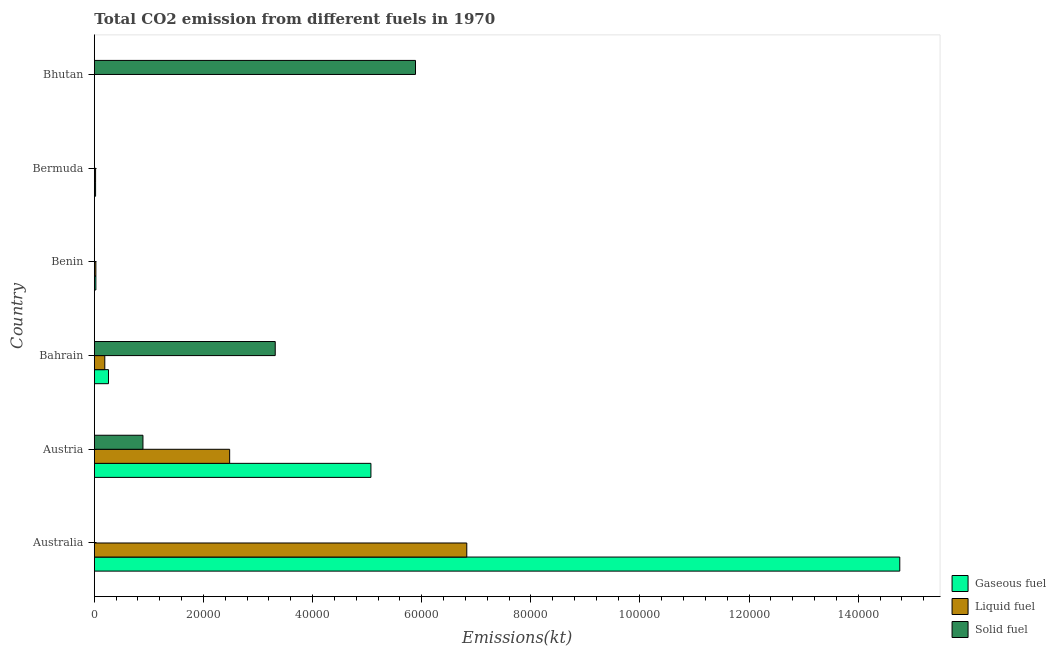How many different coloured bars are there?
Make the answer very short. 3. Are the number of bars per tick equal to the number of legend labels?
Keep it short and to the point. Yes. Are the number of bars on each tick of the Y-axis equal?
Your response must be concise. Yes. How many bars are there on the 5th tick from the top?
Your answer should be very brief. 3. What is the label of the 6th group of bars from the top?
Provide a short and direct response. Australia. In how many cases, is the number of bars for a given country not equal to the number of legend labels?
Your answer should be compact. 0. What is the amount of co2 emissions from gaseous fuel in Austria?
Your response must be concise. 5.07e+04. Across all countries, what is the maximum amount of co2 emissions from gaseous fuel?
Your answer should be very brief. 1.48e+05. Across all countries, what is the minimum amount of co2 emissions from liquid fuel?
Ensure brevity in your answer.  3.67. In which country was the amount of co2 emissions from gaseous fuel maximum?
Keep it short and to the point. Australia. What is the total amount of co2 emissions from liquid fuel in the graph?
Make the answer very short. 9.55e+04. What is the difference between the amount of co2 emissions from gaseous fuel in Australia and that in Benin?
Give a very brief answer. 1.47e+05. What is the difference between the amount of co2 emissions from solid fuel in Austria and the amount of co2 emissions from liquid fuel in Bahrain?
Your response must be concise. 6992.97. What is the average amount of co2 emissions from gaseous fuel per country?
Ensure brevity in your answer.  3.36e+04. What is the difference between the amount of co2 emissions from gaseous fuel and amount of co2 emissions from solid fuel in Austria?
Ensure brevity in your answer.  4.18e+04. What is the ratio of the amount of co2 emissions from liquid fuel in Austria to that in Bhutan?
Offer a very short reply. 6763. Is the difference between the amount of co2 emissions from gaseous fuel in Australia and Austria greater than the difference between the amount of co2 emissions from liquid fuel in Australia and Austria?
Provide a succinct answer. Yes. What is the difference between the highest and the second highest amount of co2 emissions from solid fuel?
Keep it short and to the point. 2.57e+04. What is the difference between the highest and the lowest amount of co2 emissions from solid fuel?
Provide a succinct answer. 5.89e+04. Is the sum of the amount of co2 emissions from liquid fuel in Austria and Bermuda greater than the maximum amount of co2 emissions from gaseous fuel across all countries?
Your answer should be compact. No. What does the 2nd bar from the top in Bahrain represents?
Your response must be concise. Liquid fuel. What does the 1st bar from the bottom in Austria represents?
Your answer should be compact. Gaseous fuel. Are all the bars in the graph horizontal?
Provide a succinct answer. Yes. What is the difference between two consecutive major ticks on the X-axis?
Make the answer very short. 2.00e+04. Are the values on the major ticks of X-axis written in scientific E-notation?
Provide a succinct answer. No. Does the graph contain grids?
Offer a terse response. No. Where does the legend appear in the graph?
Your answer should be very brief. Bottom right. What is the title of the graph?
Offer a very short reply. Total CO2 emission from different fuels in 1970. What is the label or title of the X-axis?
Your answer should be compact. Emissions(kt). What is the Emissions(kt) in Gaseous fuel in Australia?
Your response must be concise. 1.48e+05. What is the Emissions(kt) in Liquid fuel in Australia?
Give a very brief answer. 6.83e+04. What is the Emissions(kt) of Solid fuel in Australia?
Your answer should be compact. 3.67. What is the Emissions(kt) in Gaseous fuel in Austria?
Provide a succinct answer. 5.07e+04. What is the Emissions(kt) in Liquid fuel in Austria?
Offer a very short reply. 2.48e+04. What is the Emissions(kt) of Solid fuel in Austria?
Offer a very short reply. 8910.81. What is the Emissions(kt) in Gaseous fuel in Bahrain?
Give a very brief answer. 2592.57. What is the Emissions(kt) of Liquid fuel in Bahrain?
Provide a short and direct response. 1917.84. What is the Emissions(kt) in Solid fuel in Bahrain?
Your answer should be compact. 3.32e+04. What is the Emissions(kt) of Gaseous fuel in Benin?
Keep it short and to the point. 282.36. What is the Emissions(kt) in Liquid fuel in Benin?
Keep it short and to the point. 282.36. What is the Emissions(kt) of Solid fuel in Benin?
Give a very brief answer. 33. What is the Emissions(kt) of Gaseous fuel in Bermuda?
Offer a terse response. 227.35. What is the Emissions(kt) in Liquid fuel in Bermuda?
Keep it short and to the point. 227.35. What is the Emissions(kt) in Solid fuel in Bermuda?
Provide a succinct answer. 3.67. What is the Emissions(kt) in Gaseous fuel in Bhutan?
Your response must be concise. 3.67. What is the Emissions(kt) of Liquid fuel in Bhutan?
Make the answer very short. 3.67. What is the Emissions(kt) of Solid fuel in Bhutan?
Offer a terse response. 5.89e+04. Across all countries, what is the maximum Emissions(kt) in Gaseous fuel?
Your answer should be very brief. 1.48e+05. Across all countries, what is the maximum Emissions(kt) of Liquid fuel?
Ensure brevity in your answer.  6.83e+04. Across all countries, what is the maximum Emissions(kt) in Solid fuel?
Your answer should be very brief. 5.89e+04. Across all countries, what is the minimum Emissions(kt) of Gaseous fuel?
Offer a terse response. 3.67. Across all countries, what is the minimum Emissions(kt) in Liquid fuel?
Give a very brief answer. 3.67. Across all countries, what is the minimum Emissions(kt) in Solid fuel?
Your answer should be very brief. 3.67. What is the total Emissions(kt) in Gaseous fuel in the graph?
Give a very brief answer. 2.01e+05. What is the total Emissions(kt) of Liquid fuel in the graph?
Offer a very short reply. 9.55e+04. What is the total Emissions(kt) of Solid fuel in the graph?
Your answer should be very brief. 1.01e+05. What is the difference between the Emissions(kt) in Gaseous fuel in Australia and that in Austria?
Your answer should be very brief. 9.69e+04. What is the difference between the Emissions(kt) in Liquid fuel in Australia and that in Austria?
Your answer should be very brief. 4.35e+04. What is the difference between the Emissions(kt) in Solid fuel in Australia and that in Austria?
Offer a terse response. -8907.14. What is the difference between the Emissions(kt) in Gaseous fuel in Australia and that in Bahrain?
Provide a succinct answer. 1.45e+05. What is the difference between the Emissions(kt) in Liquid fuel in Australia and that in Bahrain?
Offer a terse response. 6.63e+04. What is the difference between the Emissions(kt) of Solid fuel in Australia and that in Bahrain?
Give a very brief answer. -3.31e+04. What is the difference between the Emissions(kt) in Gaseous fuel in Australia and that in Benin?
Keep it short and to the point. 1.47e+05. What is the difference between the Emissions(kt) in Liquid fuel in Australia and that in Benin?
Offer a very short reply. 6.80e+04. What is the difference between the Emissions(kt) of Solid fuel in Australia and that in Benin?
Make the answer very short. -29.34. What is the difference between the Emissions(kt) of Gaseous fuel in Australia and that in Bermuda?
Your answer should be compact. 1.47e+05. What is the difference between the Emissions(kt) of Liquid fuel in Australia and that in Bermuda?
Make the answer very short. 6.80e+04. What is the difference between the Emissions(kt) of Gaseous fuel in Australia and that in Bhutan?
Your answer should be very brief. 1.48e+05. What is the difference between the Emissions(kt) in Liquid fuel in Australia and that in Bhutan?
Your answer should be compact. 6.83e+04. What is the difference between the Emissions(kt) of Solid fuel in Australia and that in Bhutan?
Ensure brevity in your answer.  -5.89e+04. What is the difference between the Emissions(kt) of Gaseous fuel in Austria and that in Bahrain?
Your answer should be very brief. 4.81e+04. What is the difference between the Emissions(kt) in Liquid fuel in Austria and that in Bahrain?
Give a very brief answer. 2.29e+04. What is the difference between the Emissions(kt) in Solid fuel in Austria and that in Bahrain?
Ensure brevity in your answer.  -2.42e+04. What is the difference between the Emissions(kt) in Gaseous fuel in Austria and that in Benin?
Your response must be concise. 5.04e+04. What is the difference between the Emissions(kt) in Liquid fuel in Austria and that in Benin?
Keep it short and to the point. 2.45e+04. What is the difference between the Emissions(kt) of Solid fuel in Austria and that in Benin?
Your response must be concise. 8877.81. What is the difference between the Emissions(kt) of Gaseous fuel in Austria and that in Bermuda?
Give a very brief answer. 5.05e+04. What is the difference between the Emissions(kt) in Liquid fuel in Austria and that in Bermuda?
Your answer should be compact. 2.46e+04. What is the difference between the Emissions(kt) of Solid fuel in Austria and that in Bermuda?
Your response must be concise. 8907.14. What is the difference between the Emissions(kt) in Gaseous fuel in Austria and that in Bhutan?
Provide a short and direct response. 5.07e+04. What is the difference between the Emissions(kt) of Liquid fuel in Austria and that in Bhutan?
Keep it short and to the point. 2.48e+04. What is the difference between the Emissions(kt) in Solid fuel in Austria and that in Bhutan?
Your answer should be compact. -5.00e+04. What is the difference between the Emissions(kt) of Gaseous fuel in Bahrain and that in Benin?
Your answer should be compact. 2310.21. What is the difference between the Emissions(kt) of Liquid fuel in Bahrain and that in Benin?
Make the answer very short. 1635.48. What is the difference between the Emissions(kt) in Solid fuel in Bahrain and that in Benin?
Your answer should be very brief. 3.31e+04. What is the difference between the Emissions(kt) of Gaseous fuel in Bahrain and that in Bermuda?
Your answer should be compact. 2365.22. What is the difference between the Emissions(kt) of Liquid fuel in Bahrain and that in Bermuda?
Ensure brevity in your answer.  1690.49. What is the difference between the Emissions(kt) of Solid fuel in Bahrain and that in Bermuda?
Make the answer very short. 3.31e+04. What is the difference between the Emissions(kt) in Gaseous fuel in Bahrain and that in Bhutan?
Provide a short and direct response. 2588.9. What is the difference between the Emissions(kt) of Liquid fuel in Bahrain and that in Bhutan?
Keep it short and to the point. 1914.17. What is the difference between the Emissions(kt) in Solid fuel in Bahrain and that in Bhutan?
Offer a terse response. -2.57e+04. What is the difference between the Emissions(kt) of Gaseous fuel in Benin and that in Bermuda?
Your answer should be very brief. 55.01. What is the difference between the Emissions(kt) in Liquid fuel in Benin and that in Bermuda?
Provide a succinct answer. 55.01. What is the difference between the Emissions(kt) in Solid fuel in Benin and that in Bermuda?
Your answer should be compact. 29.34. What is the difference between the Emissions(kt) of Gaseous fuel in Benin and that in Bhutan?
Your answer should be very brief. 278.69. What is the difference between the Emissions(kt) in Liquid fuel in Benin and that in Bhutan?
Make the answer very short. 278.69. What is the difference between the Emissions(kt) in Solid fuel in Benin and that in Bhutan?
Make the answer very short. -5.88e+04. What is the difference between the Emissions(kt) of Gaseous fuel in Bermuda and that in Bhutan?
Offer a terse response. 223.69. What is the difference between the Emissions(kt) of Liquid fuel in Bermuda and that in Bhutan?
Provide a succinct answer. 223.69. What is the difference between the Emissions(kt) of Solid fuel in Bermuda and that in Bhutan?
Your answer should be compact. -5.89e+04. What is the difference between the Emissions(kt) in Gaseous fuel in Australia and the Emissions(kt) in Liquid fuel in Austria?
Ensure brevity in your answer.  1.23e+05. What is the difference between the Emissions(kt) in Gaseous fuel in Australia and the Emissions(kt) in Solid fuel in Austria?
Ensure brevity in your answer.  1.39e+05. What is the difference between the Emissions(kt) in Liquid fuel in Australia and the Emissions(kt) in Solid fuel in Austria?
Your response must be concise. 5.94e+04. What is the difference between the Emissions(kt) in Gaseous fuel in Australia and the Emissions(kt) in Liquid fuel in Bahrain?
Your answer should be compact. 1.46e+05. What is the difference between the Emissions(kt) in Gaseous fuel in Australia and the Emissions(kt) in Solid fuel in Bahrain?
Give a very brief answer. 1.14e+05. What is the difference between the Emissions(kt) of Liquid fuel in Australia and the Emissions(kt) of Solid fuel in Bahrain?
Give a very brief answer. 3.51e+04. What is the difference between the Emissions(kt) in Gaseous fuel in Australia and the Emissions(kt) in Liquid fuel in Benin?
Make the answer very short. 1.47e+05. What is the difference between the Emissions(kt) of Gaseous fuel in Australia and the Emissions(kt) of Solid fuel in Benin?
Provide a short and direct response. 1.48e+05. What is the difference between the Emissions(kt) of Liquid fuel in Australia and the Emissions(kt) of Solid fuel in Benin?
Provide a succinct answer. 6.82e+04. What is the difference between the Emissions(kt) of Gaseous fuel in Australia and the Emissions(kt) of Liquid fuel in Bermuda?
Provide a succinct answer. 1.47e+05. What is the difference between the Emissions(kt) in Gaseous fuel in Australia and the Emissions(kt) in Solid fuel in Bermuda?
Make the answer very short. 1.48e+05. What is the difference between the Emissions(kt) in Liquid fuel in Australia and the Emissions(kt) in Solid fuel in Bermuda?
Ensure brevity in your answer.  6.83e+04. What is the difference between the Emissions(kt) in Gaseous fuel in Australia and the Emissions(kt) in Liquid fuel in Bhutan?
Your answer should be compact. 1.48e+05. What is the difference between the Emissions(kt) of Gaseous fuel in Australia and the Emissions(kt) of Solid fuel in Bhutan?
Keep it short and to the point. 8.88e+04. What is the difference between the Emissions(kt) in Liquid fuel in Australia and the Emissions(kt) in Solid fuel in Bhutan?
Offer a terse response. 9398.52. What is the difference between the Emissions(kt) of Gaseous fuel in Austria and the Emissions(kt) of Liquid fuel in Bahrain?
Keep it short and to the point. 4.88e+04. What is the difference between the Emissions(kt) in Gaseous fuel in Austria and the Emissions(kt) in Solid fuel in Bahrain?
Offer a very short reply. 1.75e+04. What is the difference between the Emissions(kt) of Liquid fuel in Austria and the Emissions(kt) of Solid fuel in Bahrain?
Your response must be concise. -8353.43. What is the difference between the Emissions(kt) in Gaseous fuel in Austria and the Emissions(kt) in Liquid fuel in Benin?
Provide a succinct answer. 5.04e+04. What is the difference between the Emissions(kt) of Gaseous fuel in Austria and the Emissions(kt) of Solid fuel in Benin?
Your answer should be very brief. 5.07e+04. What is the difference between the Emissions(kt) of Liquid fuel in Austria and the Emissions(kt) of Solid fuel in Benin?
Your response must be concise. 2.48e+04. What is the difference between the Emissions(kt) of Gaseous fuel in Austria and the Emissions(kt) of Liquid fuel in Bermuda?
Keep it short and to the point. 5.05e+04. What is the difference between the Emissions(kt) in Gaseous fuel in Austria and the Emissions(kt) in Solid fuel in Bermuda?
Ensure brevity in your answer.  5.07e+04. What is the difference between the Emissions(kt) in Liquid fuel in Austria and the Emissions(kt) in Solid fuel in Bermuda?
Keep it short and to the point. 2.48e+04. What is the difference between the Emissions(kt) of Gaseous fuel in Austria and the Emissions(kt) of Liquid fuel in Bhutan?
Offer a very short reply. 5.07e+04. What is the difference between the Emissions(kt) in Gaseous fuel in Austria and the Emissions(kt) in Solid fuel in Bhutan?
Provide a succinct answer. -8170.08. What is the difference between the Emissions(kt) in Liquid fuel in Austria and the Emissions(kt) in Solid fuel in Bhutan?
Make the answer very short. -3.41e+04. What is the difference between the Emissions(kt) in Gaseous fuel in Bahrain and the Emissions(kt) in Liquid fuel in Benin?
Offer a terse response. 2310.21. What is the difference between the Emissions(kt) in Gaseous fuel in Bahrain and the Emissions(kt) in Solid fuel in Benin?
Make the answer very short. 2559.57. What is the difference between the Emissions(kt) in Liquid fuel in Bahrain and the Emissions(kt) in Solid fuel in Benin?
Provide a succinct answer. 1884.84. What is the difference between the Emissions(kt) in Gaseous fuel in Bahrain and the Emissions(kt) in Liquid fuel in Bermuda?
Ensure brevity in your answer.  2365.22. What is the difference between the Emissions(kt) of Gaseous fuel in Bahrain and the Emissions(kt) of Solid fuel in Bermuda?
Offer a terse response. 2588.9. What is the difference between the Emissions(kt) of Liquid fuel in Bahrain and the Emissions(kt) of Solid fuel in Bermuda?
Offer a terse response. 1914.17. What is the difference between the Emissions(kt) in Gaseous fuel in Bahrain and the Emissions(kt) in Liquid fuel in Bhutan?
Keep it short and to the point. 2588.9. What is the difference between the Emissions(kt) in Gaseous fuel in Bahrain and the Emissions(kt) in Solid fuel in Bhutan?
Offer a very short reply. -5.63e+04. What is the difference between the Emissions(kt) in Liquid fuel in Bahrain and the Emissions(kt) in Solid fuel in Bhutan?
Your answer should be very brief. -5.69e+04. What is the difference between the Emissions(kt) of Gaseous fuel in Benin and the Emissions(kt) of Liquid fuel in Bermuda?
Provide a short and direct response. 55.01. What is the difference between the Emissions(kt) of Gaseous fuel in Benin and the Emissions(kt) of Solid fuel in Bermuda?
Keep it short and to the point. 278.69. What is the difference between the Emissions(kt) of Liquid fuel in Benin and the Emissions(kt) of Solid fuel in Bermuda?
Offer a terse response. 278.69. What is the difference between the Emissions(kt) of Gaseous fuel in Benin and the Emissions(kt) of Liquid fuel in Bhutan?
Make the answer very short. 278.69. What is the difference between the Emissions(kt) in Gaseous fuel in Benin and the Emissions(kt) in Solid fuel in Bhutan?
Provide a succinct answer. -5.86e+04. What is the difference between the Emissions(kt) in Liquid fuel in Benin and the Emissions(kt) in Solid fuel in Bhutan?
Your response must be concise. -5.86e+04. What is the difference between the Emissions(kt) of Gaseous fuel in Bermuda and the Emissions(kt) of Liquid fuel in Bhutan?
Your answer should be very brief. 223.69. What is the difference between the Emissions(kt) in Gaseous fuel in Bermuda and the Emissions(kt) in Solid fuel in Bhutan?
Your response must be concise. -5.86e+04. What is the difference between the Emissions(kt) of Liquid fuel in Bermuda and the Emissions(kt) of Solid fuel in Bhutan?
Give a very brief answer. -5.86e+04. What is the average Emissions(kt) in Gaseous fuel per country?
Your answer should be compact. 3.36e+04. What is the average Emissions(kt) of Liquid fuel per country?
Ensure brevity in your answer.  1.59e+04. What is the average Emissions(kt) of Solid fuel per country?
Ensure brevity in your answer.  1.68e+04. What is the difference between the Emissions(kt) of Gaseous fuel and Emissions(kt) of Liquid fuel in Australia?
Keep it short and to the point. 7.94e+04. What is the difference between the Emissions(kt) in Gaseous fuel and Emissions(kt) in Solid fuel in Australia?
Your response must be concise. 1.48e+05. What is the difference between the Emissions(kt) in Liquid fuel and Emissions(kt) in Solid fuel in Australia?
Offer a terse response. 6.83e+04. What is the difference between the Emissions(kt) in Gaseous fuel and Emissions(kt) in Liquid fuel in Austria?
Your answer should be very brief. 2.59e+04. What is the difference between the Emissions(kt) of Gaseous fuel and Emissions(kt) of Solid fuel in Austria?
Keep it short and to the point. 4.18e+04. What is the difference between the Emissions(kt) of Liquid fuel and Emissions(kt) of Solid fuel in Austria?
Give a very brief answer. 1.59e+04. What is the difference between the Emissions(kt) of Gaseous fuel and Emissions(kt) of Liquid fuel in Bahrain?
Provide a short and direct response. 674.73. What is the difference between the Emissions(kt) of Gaseous fuel and Emissions(kt) of Solid fuel in Bahrain?
Offer a terse response. -3.06e+04. What is the difference between the Emissions(kt) of Liquid fuel and Emissions(kt) of Solid fuel in Bahrain?
Provide a succinct answer. -3.12e+04. What is the difference between the Emissions(kt) of Gaseous fuel and Emissions(kt) of Liquid fuel in Benin?
Ensure brevity in your answer.  0. What is the difference between the Emissions(kt) of Gaseous fuel and Emissions(kt) of Solid fuel in Benin?
Offer a terse response. 249.36. What is the difference between the Emissions(kt) in Liquid fuel and Emissions(kt) in Solid fuel in Benin?
Make the answer very short. 249.36. What is the difference between the Emissions(kt) of Gaseous fuel and Emissions(kt) of Solid fuel in Bermuda?
Give a very brief answer. 223.69. What is the difference between the Emissions(kt) of Liquid fuel and Emissions(kt) of Solid fuel in Bermuda?
Your response must be concise. 223.69. What is the difference between the Emissions(kt) in Gaseous fuel and Emissions(kt) in Solid fuel in Bhutan?
Your answer should be compact. -5.89e+04. What is the difference between the Emissions(kt) in Liquid fuel and Emissions(kt) in Solid fuel in Bhutan?
Your answer should be very brief. -5.89e+04. What is the ratio of the Emissions(kt) in Gaseous fuel in Australia to that in Austria?
Ensure brevity in your answer.  2.91. What is the ratio of the Emissions(kt) in Liquid fuel in Australia to that in Austria?
Offer a terse response. 2.75. What is the ratio of the Emissions(kt) in Gaseous fuel in Australia to that in Bahrain?
Give a very brief answer. 56.94. What is the ratio of the Emissions(kt) of Liquid fuel in Australia to that in Bahrain?
Your response must be concise. 35.59. What is the ratio of the Emissions(kt) of Solid fuel in Australia to that in Bahrain?
Give a very brief answer. 0. What is the ratio of the Emissions(kt) of Gaseous fuel in Australia to that in Benin?
Give a very brief answer. 522.81. What is the ratio of the Emissions(kt) in Liquid fuel in Australia to that in Benin?
Provide a succinct answer. 241.75. What is the ratio of the Emissions(kt) in Gaseous fuel in Australia to that in Bermuda?
Make the answer very short. 649.29. What is the ratio of the Emissions(kt) of Liquid fuel in Australia to that in Bermuda?
Offer a very short reply. 300.24. What is the ratio of the Emissions(kt) of Gaseous fuel in Australia to that in Bhutan?
Offer a terse response. 4.03e+04. What is the ratio of the Emissions(kt) of Liquid fuel in Australia to that in Bhutan?
Your answer should be compact. 1.86e+04. What is the ratio of the Emissions(kt) in Solid fuel in Australia to that in Bhutan?
Ensure brevity in your answer.  0. What is the ratio of the Emissions(kt) in Gaseous fuel in Austria to that in Bahrain?
Offer a terse response. 19.55. What is the ratio of the Emissions(kt) in Liquid fuel in Austria to that in Bahrain?
Keep it short and to the point. 12.93. What is the ratio of the Emissions(kt) of Solid fuel in Austria to that in Bahrain?
Offer a very short reply. 0.27. What is the ratio of the Emissions(kt) in Gaseous fuel in Austria to that in Benin?
Your response must be concise. 179.53. What is the ratio of the Emissions(kt) in Liquid fuel in Austria to that in Benin?
Your response must be concise. 87.83. What is the ratio of the Emissions(kt) in Solid fuel in Austria to that in Benin?
Your answer should be compact. 270. What is the ratio of the Emissions(kt) of Gaseous fuel in Austria to that in Bermuda?
Make the answer very short. 222.97. What is the ratio of the Emissions(kt) of Liquid fuel in Austria to that in Bermuda?
Give a very brief answer. 109.08. What is the ratio of the Emissions(kt) in Solid fuel in Austria to that in Bermuda?
Offer a terse response. 2430. What is the ratio of the Emissions(kt) of Gaseous fuel in Austria to that in Bhutan?
Make the answer very short. 1.38e+04. What is the ratio of the Emissions(kt) of Liquid fuel in Austria to that in Bhutan?
Provide a short and direct response. 6763. What is the ratio of the Emissions(kt) in Solid fuel in Austria to that in Bhutan?
Make the answer very short. 0.15. What is the ratio of the Emissions(kt) in Gaseous fuel in Bahrain to that in Benin?
Ensure brevity in your answer.  9.18. What is the ratio of the Emissions(kt) of Liquid fuel in Bahrain to that in Benin?
Your answer should be compact. 6.79. What is the ratio of the Emissions(kt) of Solid fuel in Bahrain to that in Benin?
Make the answer very short. 1004.56. What is the ratio of the Emissions(kt) of Gaseous fuel in Bahrain to that in Bermuda?
Your response must be concise. 11.4. What is the ratio of the Emissions(kt) in Liquid fuel in Bahrain to that in Bermuda?
Your answer should be very brief. 8.44. What is the ratio of the Emissions(kt) of Solid fuel in Bahrain to that in Bermuda?
Your answer should be compact. 9041. What is the ratio of the Emissions(kt) of Gaseous fuel in Bahrain to that in Bhutan?
Your response must be concise. 707. What is the ratio of the Emissions(kt) in Liquid fuel in Bahrain to that in Bhutan?
Make the answer very short. 523. What is the ratio of the Emissions(kt) in Solid fuel in Bahrain to that in Bhutan?
Give a very brief answer. 0.56. What is the ratio of the Emissions(kt) of Gaseous fuel in Benin to that in Bermuda?
Your answer should be compact. 1.24. What is the ratio of the Emissions(kt) in Liquid fuel in Benin to that in Bermuda?
Your answer should be compact. 1.24. What is the ratio of the Emissions(kt) in Liquid fuel in Benin to that in Bhutan?
Provide a succinct answer. 77. What is the ratio of the Emissions(kt) of Solid fuel in Benin to that in Bhutan?
Provide a succinct answer. 0. What is the ratio of the Emissions(kt) of Liquid fuel in Bermuda to that in Bhutan?
Provide a short and direct response. 62. What is the ratio of the Emissions(kt) in Solid fuel in Bermuda to that in Bhutan?
Provide a succinct answer. 0. What is the difference between the highest and the second highest Emissions(kt) in Gaseous fuel?
Give a very brief answer. 9.69e+04. What is the difference between the highest and the second highest Emissions(kt) in Liquid fuel?
Your answer should be compact. 4.35e+04. What is the difference between the highest and the second highest Emissions(kt) in Solid fuel?
Keep it short and to the point. 2.57e+04. What is the difference between the highest and the lowest Emissions(kt) of Gaseous fuel?
Make the answer very short. 1.48e+05. What is the difference between the highest and the lowest Emissions(kt) in Liquid fuel?
Your answer should be compact. 6.83e+04. What is the difference between the highest and the lowest Emissions(kt) of Solid fuel?
Your answer should be compact. 5.89e+04. 